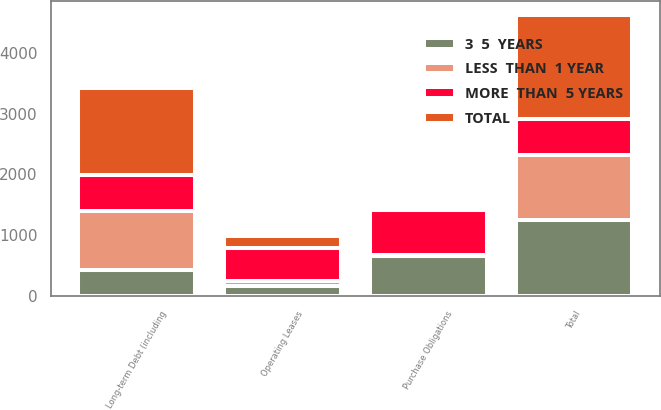<chart> <loc_0><loc_0><loc_500><loc_500><stacked_bar_chart><ecel><fcel>Long-term Debt (including<fcel>Operating Leases<fcel>Purchase Obligations<fcel>Total<nl><fcel>MORE  THAN  5 YEARS<fcel>595.5<fcel>536<fcel>746<fcel>595.5<nl><fcel>3  5  YEARS<fcel>428<fcel>171<fcel>655<fcel>1254<nl><fcel>TOTAL<fcel>1434<fcel>206<fcel>71<fcel>1711<nl><fcel>LESS  THAN  1 YEAR<fcel>966<fcel>80<fcel>14<fcel>1060<nl></chart> 